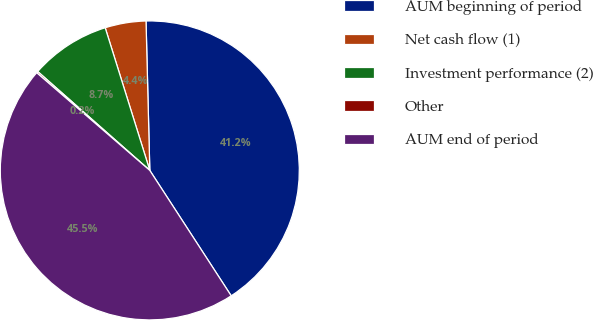Convert chart to OTSL. <chart><loc_0><loc_0><loc_500><loc_500><pie_chart><fcel>AUM beginning of period<fcel>Net cash flow (1)<fcel>Investment performance (2)<fcel>Other<fcel>AUM end of period<nl><fcel>41.24%<fcel>4.42%<fcel>8.67%<fcel>0.17%<fcel>45.5%<nl></chart> 